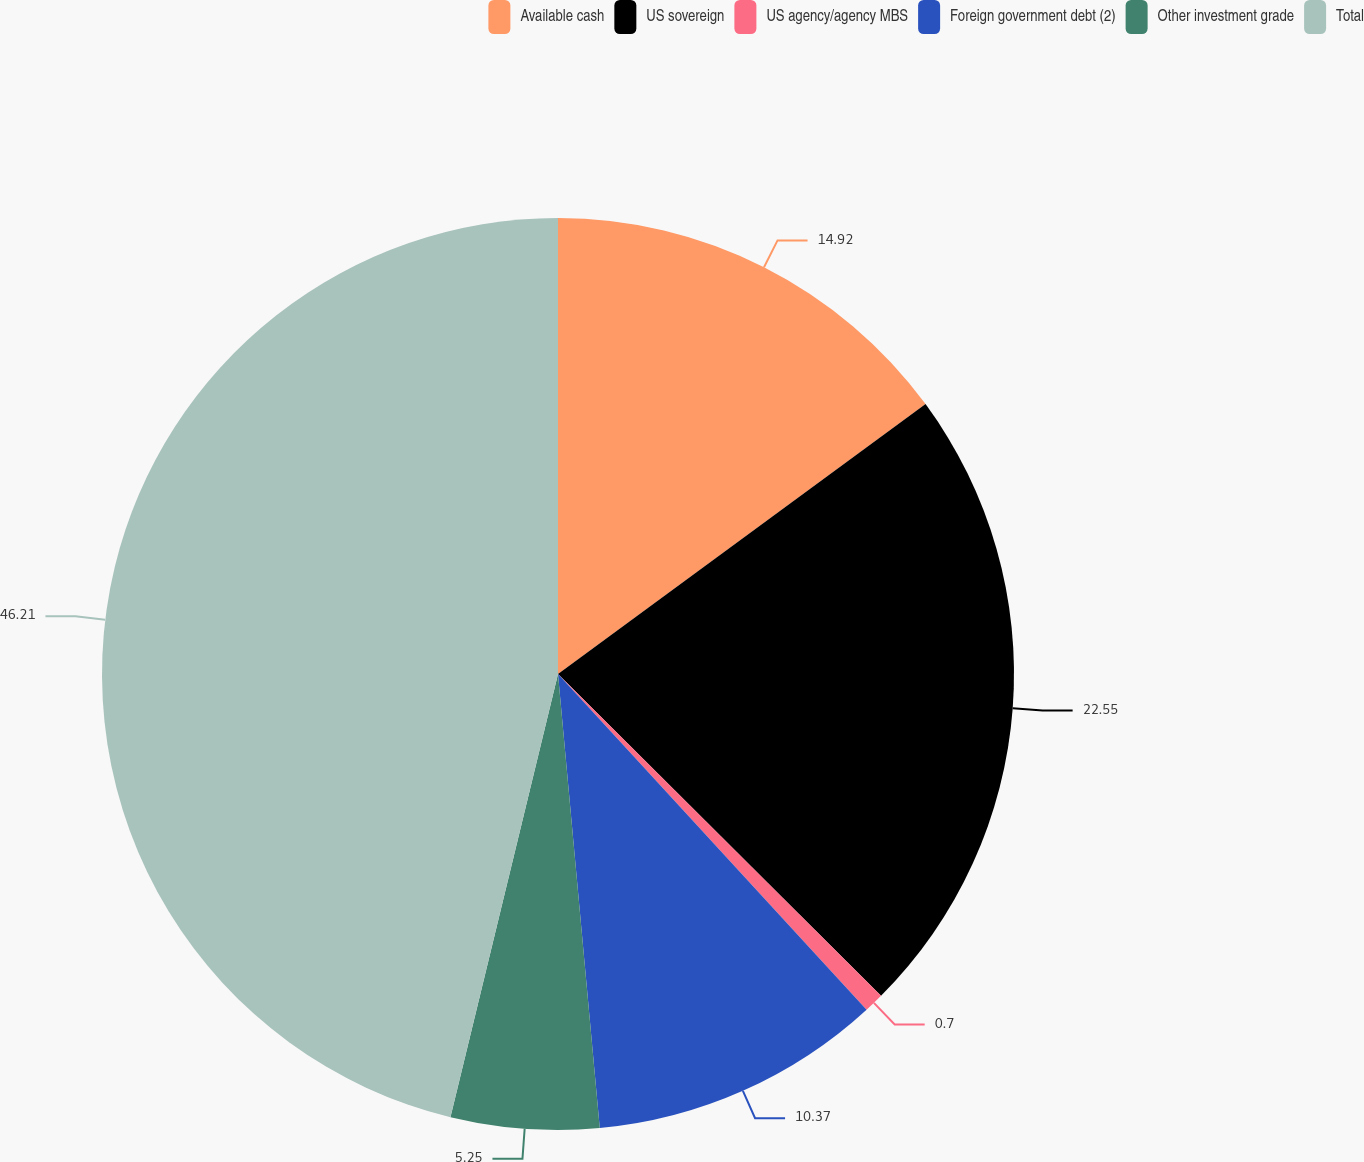Convert chart to OTSL. <chart><loc_0><loc_0><loc_500><loc_500><pie_chart><fcel>Available cash<fcel>US sovereign<fcel>US agency/agency MBS<fcel>Foreign government debt (2)<fcel>Other investment grade<fcel>Total<nl><fcel>14.92%<fcel>22.55%<fcel>0.7%<fcel>10.37%<fcel>5.25%<fcel>46.21%<nl></chart> 